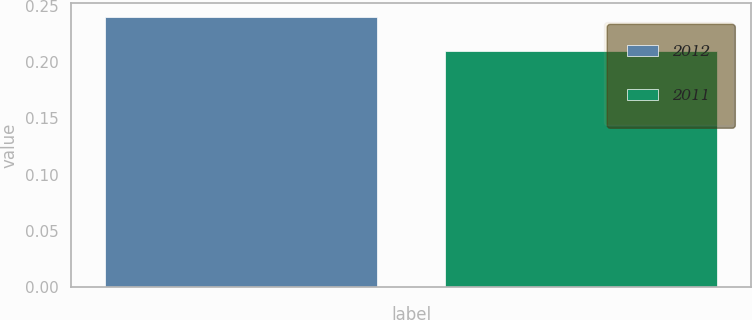Convert chart. <chart><loc_0><loc_0><loc_500><loc_500><bar_chart><fcel>2012<fcel>2011<nl><fcel>0.24<fcel>0.21<nl></chart> 